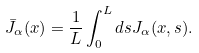Convert formula to latex. <formula><loc_0><loc_0><loc_500><loc_500>\bar { J } _ { \alpha } ( x ) = \frac { 1 } { L } \int _ { 0 } ^ { L } d s J _ { \alpha } ( x , s ) .</formula> 